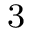Convert formula to latex. <formula><loc_0><loc_0><loc_500><loc_500>^ { 3 }</formula> 